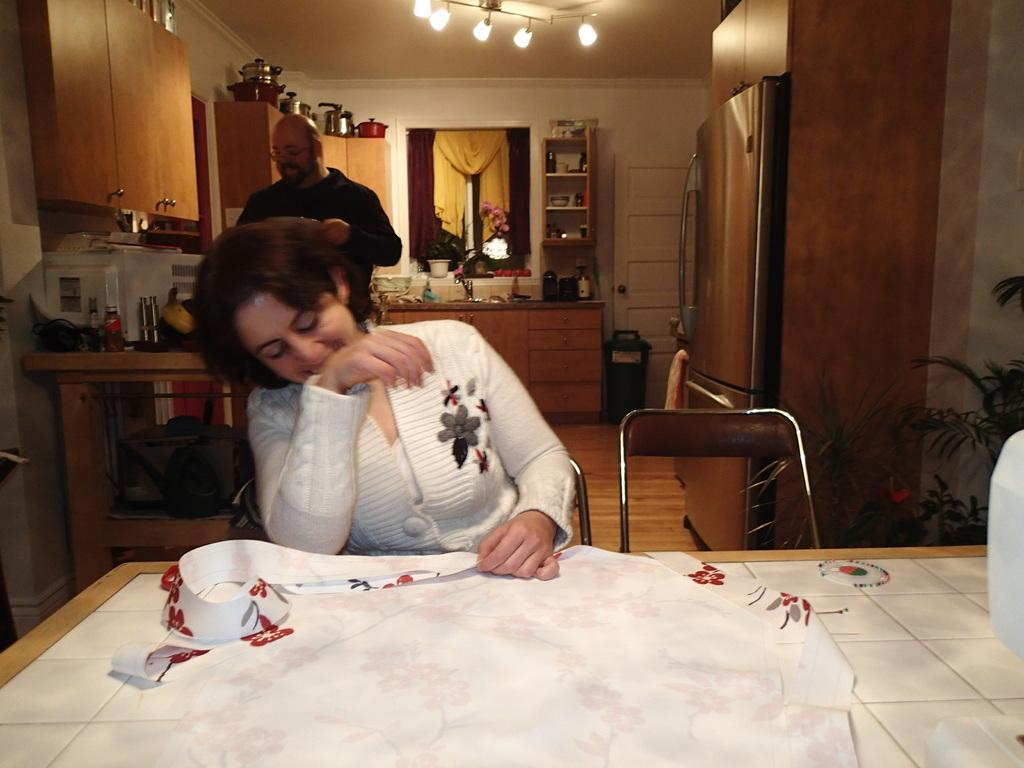What is the woman in the image doing? The woman is sitting in a chair in the image. What is in front of the woman? The woman is in front of a table. What type of room is depicted in the image? The setting appears to be a kitchen. What can be seen on the ceiling in the image? There are lights on the ceiling. Who else is present in the image? There is a man behind the woman. What type of tin can be seen on the slope in the image? There is no tin or slope present in the image; it depicts a woman sitting in a chair in a kitchen setting. 